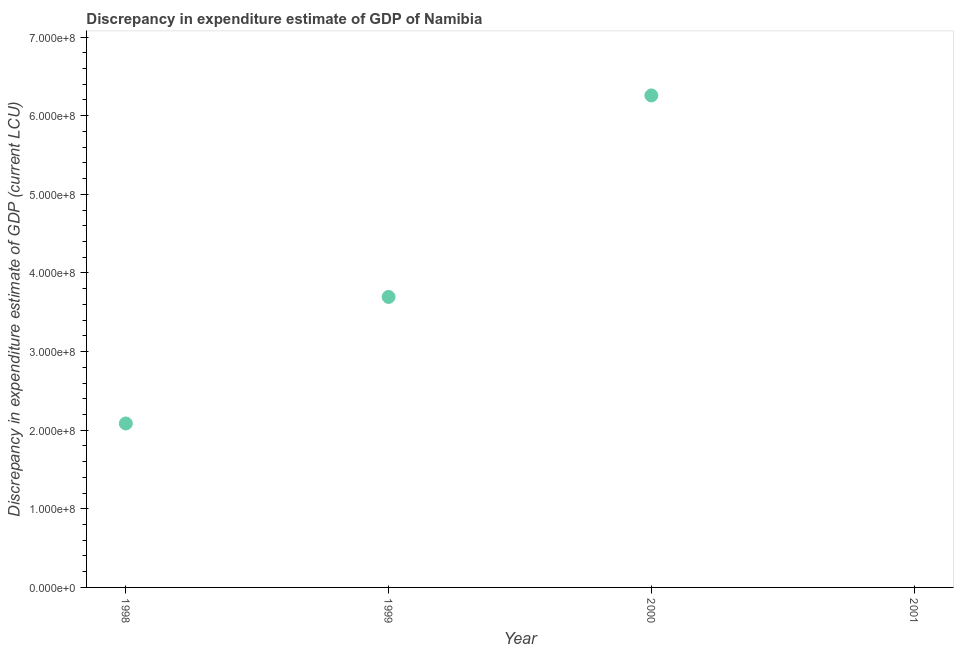What is the discrepancy in expenditure estimate of gdp in 1999?
Your answer should be very brief. 3.69e+08. Across all years, what is the maximum discrepancy in expenditure estimate of gdp?
Give a very brief answer. 6.26e+08. What is the sum of the discrepancy in expenditure estimate of gdp?
Provide a short and direct response. 1.20e+09. What is the difference between the discrepancy in expenditure estimate of gdp in 1999 and 2000?
Offer a terse response. -2.56e+08. What is the average discrepancy in expenditure estimate of gdp per year?
Provide a succinct answer. 3.01e+08. What is the median discrepancy in expenditure estimate of gdp?
Give a very brief answer. 2.89e+08. In how many years, is the discrepancy in expenditure estimate of gdp greater than 580000000 LCU?
Your answer should be very brief. 1. What is the ratio of the discrepancy in expenditure estimate of gdp in 1998 to that in 2000?
Provide a succinct answer. 0.33. Is the difference between the discrepancy in expenditure estimate of gdp in 1998 and 2000 greater than the difference between any two years?
Give a very brief answer. No. What is the difference between the highest and the second highest discrepancy in expenditure estimate of gdp?
Ensure brevity in your answer.  2.56e+08. Is the sum of the discrepancy in expenditure estimate of gdp in 1998 and 2000 greater than the maximum discrepancy in expenditure estimate of gdp across all years?
Give a very brief answer. Yes. What is the difference between the highest and the lowest discrepancy in expenditure estimate of gdp?
Make the answer very short. 6.26e+08. How many years are there in the graph?
Your answer should be compact. 4. What is the difference between two consecutive major ticks on the Y-axis?
Give a very brief answer. 1.00e+08. Are the values on the major ticks of Y-axis written in scientific E-notation?
Offer a very short reply. Yes. What is the title of the graph?
Give a very brief answer. Discrepancy in expenditure estimate of GDP of Namibia. What is the label or title of the Y-axis?
Your answer should be very brief. Discrepancy in expenditure estimate of GDP (current LCU). What is the Discrepancy in expenditure estimate of GDP (current LCU) in 1998?
Give a very brief answer. 2.09e+08. What is the Discrepancy in expenditure estimate of GDP (current LCU) in 1999?
Give a very brief answer. 3.69e+08. What is the Discrepancy in expenditure estimate of GDP (current LCU) in 2000?
Provide a short and direct response. 6.26e+08. What is the Discrepancy in expenditure estimate of GDP (current LCU) in 2001?
Provide a succinct answer. 0. What is the difference between the Discrepancy in expenditure estimate of GDP (current LCU) in 1998 and 1999?
Offer a terse response. -1.61e+08. What is the difference between the Discrepancy in expenditure estimate of GDP (current LCU) in 1998 and 2000?
Provide a short and direct response. -4.17e+08. What is the difference between the Discrepancy in expenditure estimate of GDP (current LCU) in 1999 and 2000?
Your answer should be very brief. -2.56e+08. What is the ratio of the Discrepancy in expenditure estimate of GDP (current LCU) in 1998 to that in 1999?
Ensure brevity in your answer.  0.56. What is the ratio of the Discrepancy in expenditure estimate of GDP (current LCU) in 1998 to that in 2000?
Give a very brief answer. 0.33. What is the ratio of the Discrepancy in expenditure estimate of GDP (current LCU) in 1999 to that in 2000?
Give a very brief answer. 0.59. 